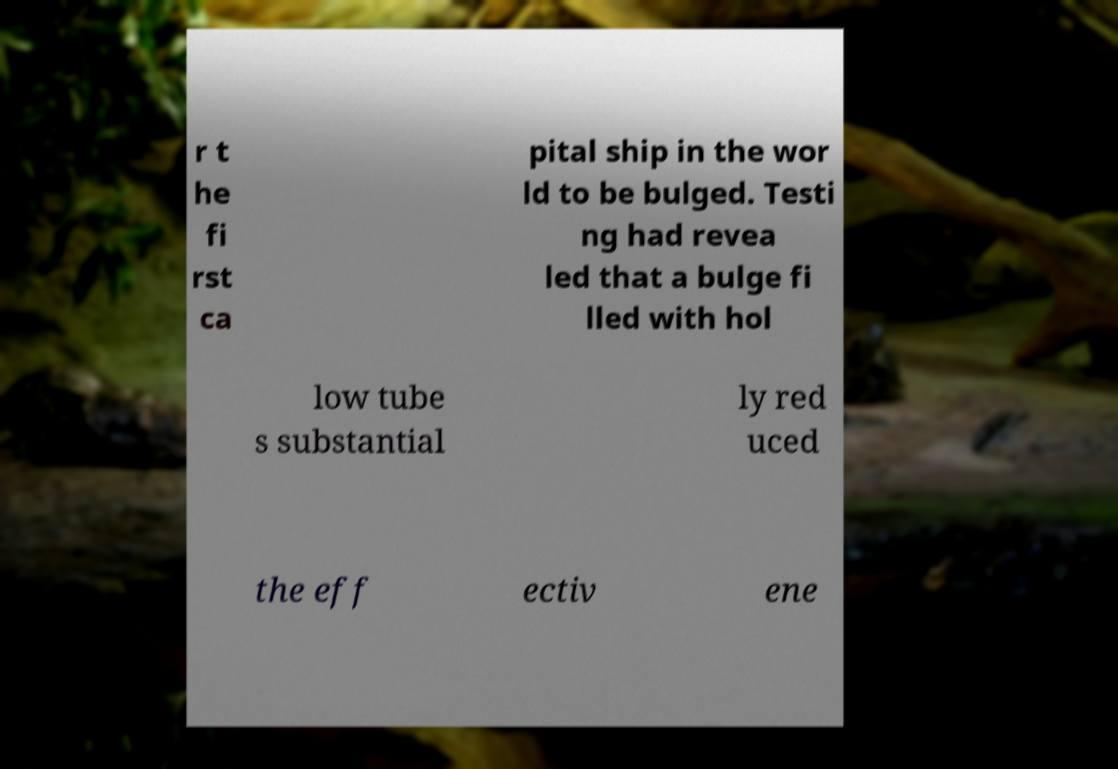There's text embedded in this image that I need extracted. Can you transcribe it verbatim? r t he fi rst ca pital ship in the wor ld to be bulged. Testi ng had revea led that a bulge fi lled with hol low tube s substantial ly red uced the eff ectiv ene 